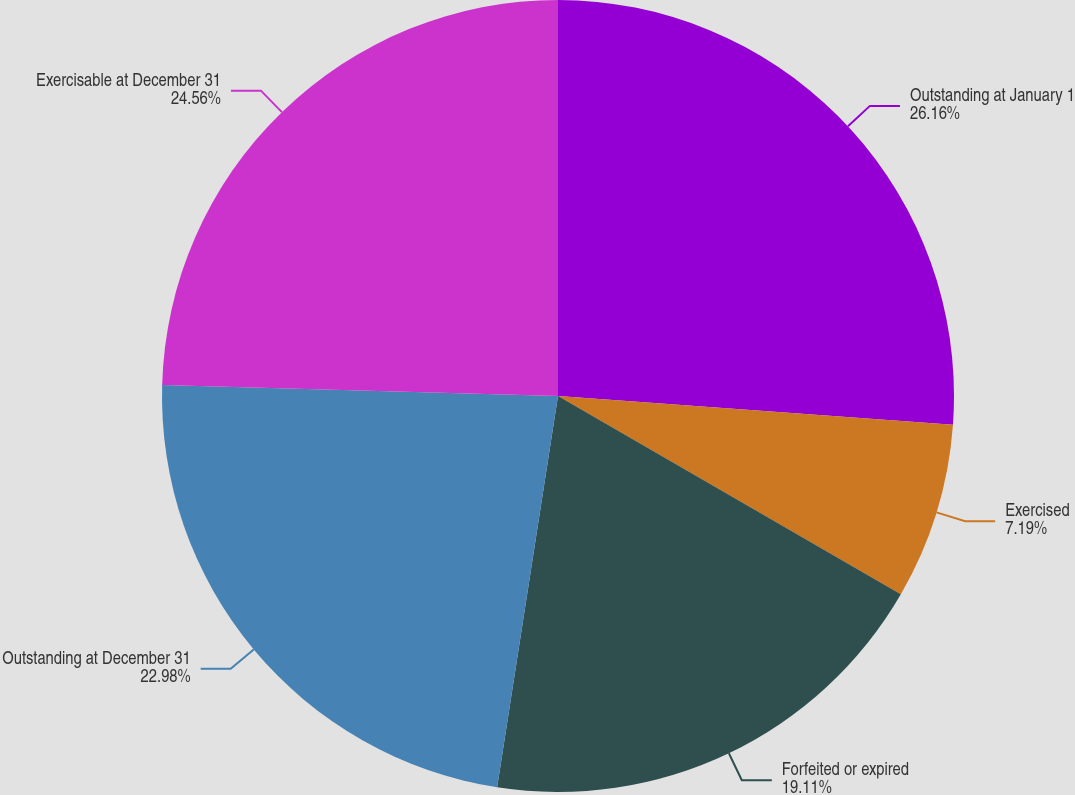Convert chart. <chart><loc_0><loc_0><loc_500><loc_500><pie_chart><fcel>Outstanding at January 1<fcel>Exercised<fcel>Forfeited or expired<fcel>Outstanding at December 31<fcel>Exercisable at December 31<nl><fcel>26.15%<fcel>7.19%<fcel>19.11%<fcel>22.98%<fcel>24.56%<nl></chart> 